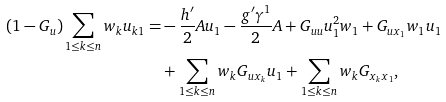<formula> <loc_0><loc_0><loc_500><loc_500>( 1 - G _ { u } ) \sum _ { 1 \leq k \leq n } w _ { k } u _ { k 1 } = & - \frac { h ^ { \prime } } { 2 } A u _ { 1 } - \frac { g ^ { \prime } \gamma ^ { 1 } } { 2 } A + G _ { u u } u _ { 1 } ^ { 2 } w _ { 1 } + G _ { u x _ { 1 } } w _ { 1 } u _ { 1 } \\ & + \sum _ { 1 \leq k \leq n } w _ { k } G _ { u x _ { k } } u _ { 1 } + \sum _ { 1 \leq k \leq n } w _ { k } G _ { x _ { k } x _ { 1 } } ,</formula> 